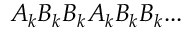Convert formula to latex. <formula><loc_0><loc_0><loc_500><loc_500>A _ { k } B _ { k } B _ { k } A _ { k } B _ { k } B _ { k } \dots</formula> 